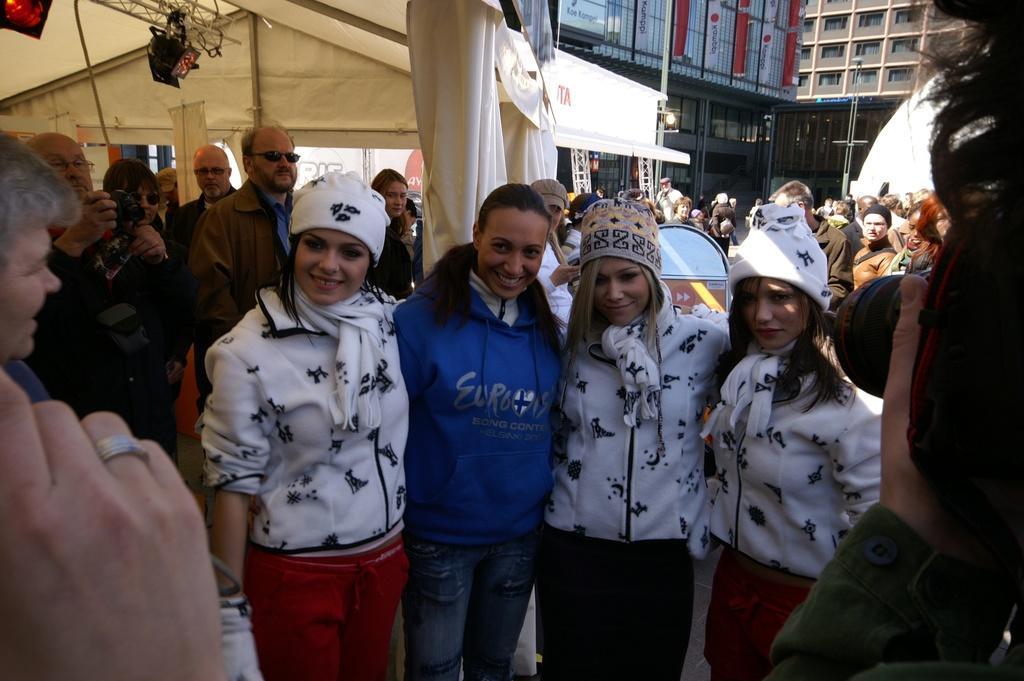Please provide a concise description of this image. In this image I can see few people standing and wearing different color dresses. One person is holding a camera. Back I can see few buildings,windows,tents,poles and lights. 